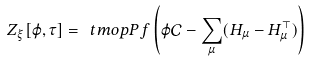Convert formula to latex. <formula><loc_0><loc_0><loc_500><loc_500>Z _ { \xi } [ \varphi , \tau ] = \ t m o p { P f } \left ( \varphi \mathcal { C } - \sum _ { \mu } ( H _ { \mu } - H _ { \mu } ^ { \top } ) \right )</formula> 